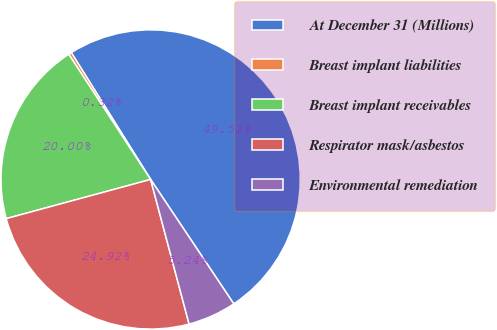Convert chart. <chart><loc_0><loc_0><loc_500><loc_500><pie_chart><fcel>At December 31 (Millions)<fcel>Breast implant liabilities<fcel>Breast implant receivables<fcel>Respirator mask/asbestos<fcel>Environmental remediation<nl><fcel>49.52%<fcel>0.32%<fcel>20.0%<fcel>24.92%<fcel>5.24%<nl></chart> 